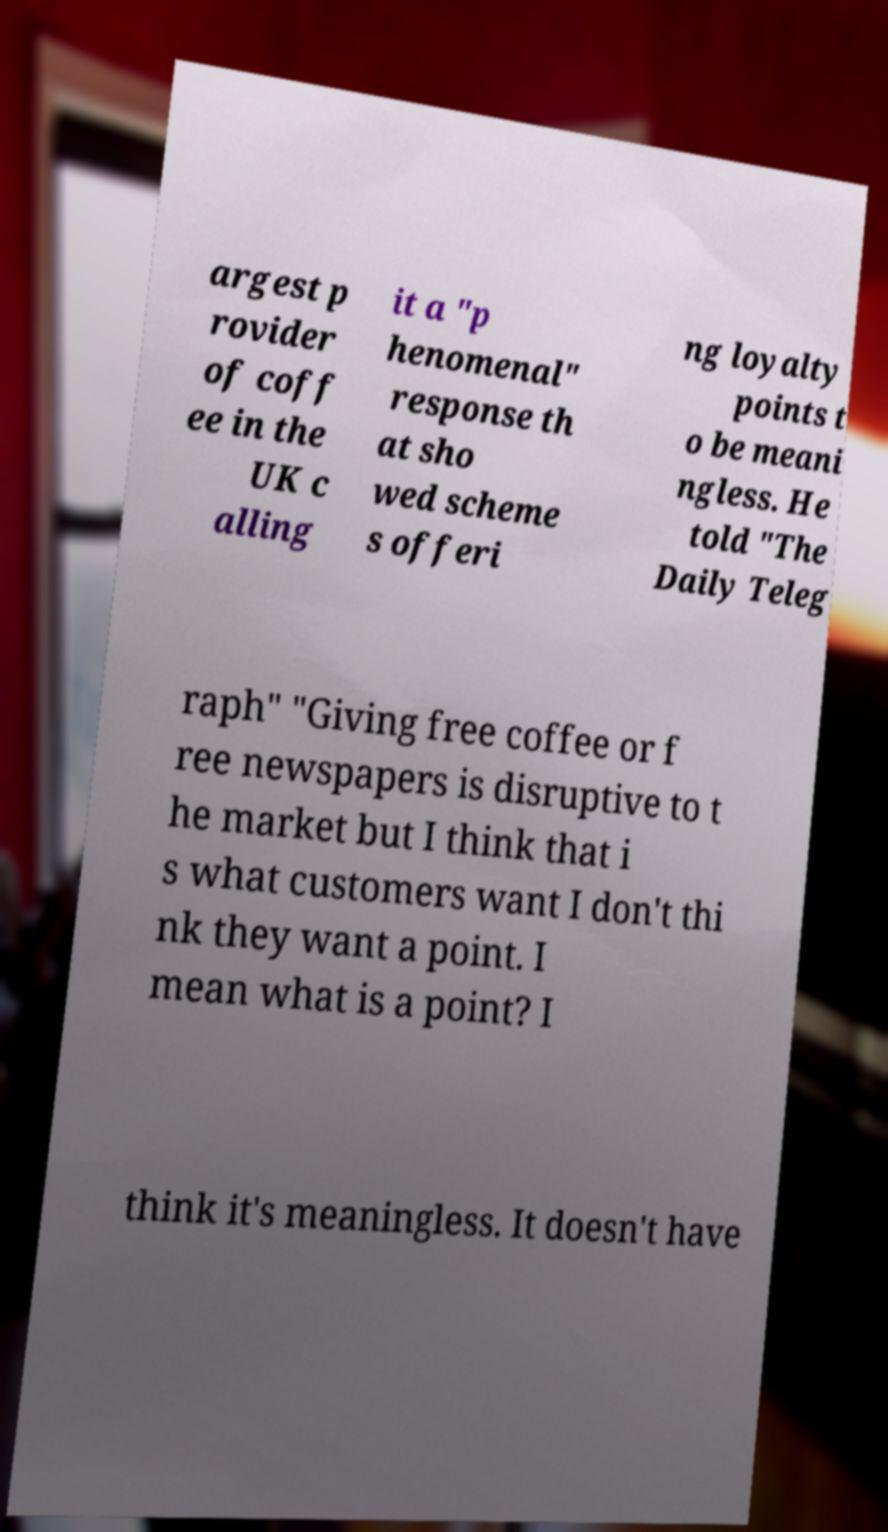I need the written content from this picture converted into text. Can you do that? argest p rovider of coff ee in the UK c alling it a "p henomenal" response th at sho wed scheme s offeri ng loyalty points t o be meani ngless. He told "The Daily Teleg raph" "Giving free coffee or f ree newspapers is disruptive to t he market but I think that i s what customers want I don't thi nk they want a point. I mean what is a point? I think it's meaningless. It doesn't have 